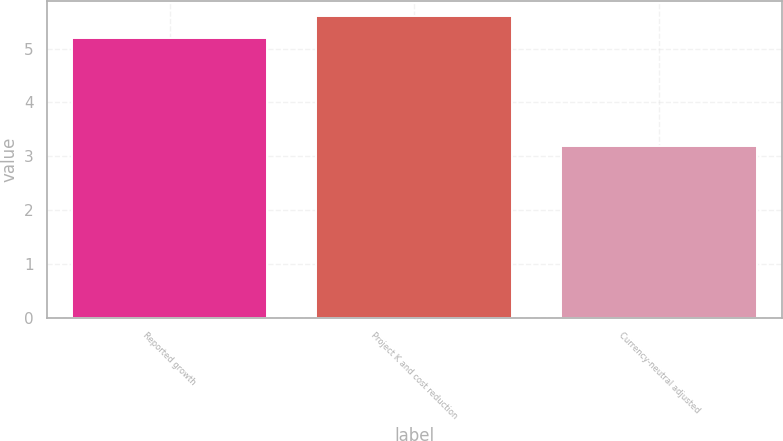Convert chart. <chart><loc_0><loc_0><loc_500><loc_500><bar_chart><fcel>Reported growth<fcel>Project K and cost reduction<fcel>Currency-neutral adjusted<nl><fcel>5.2<fcel>5.6<fcel>3.2<nl></chart> 